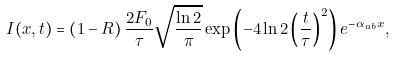<formula> <loc_0><loc_0><loc_500><loc_500>I ( x , t ) = \left ( { 1 - R } \right ) \frac { 2 F _ { 0 } } { \tau } \sqrt { \frac { \ln 2 } { \pi } } \exp \left ( { - 4 \ln 2 \left ( { \frac { t } { \tau } } \right ) ^ { 2 } } \right ) e ^ { - \alpha _ { a b } x } ,</formula> 